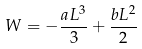<formula> <loc_0><loc_0><loc_500><loc_500>W = - \frac { a L ^ { 3 } } { 3 } + \frac { b L ^ { 2 } } { 2 }</formula> 